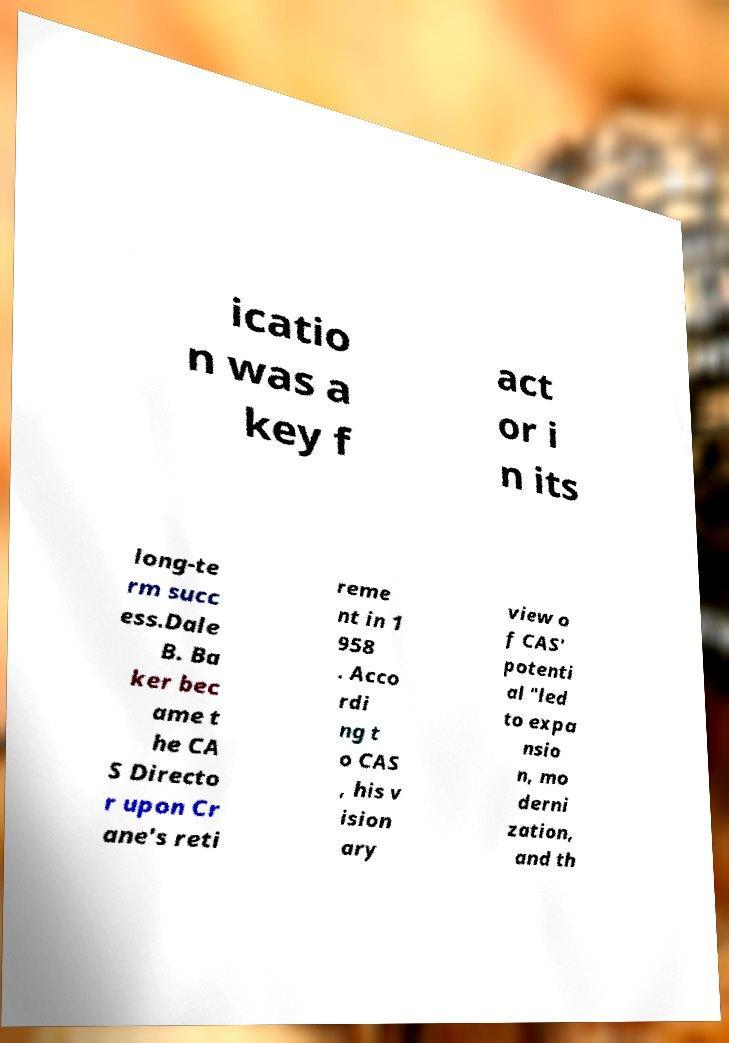Can you accurately transcribe the text from the provided image for me? icatio n was a key f act or i n its long-te rm succ ess.Dale B. Ba ker bec ame t he CA S Directo r upon Cr ane's reti reme nt in 1 958 . Acco rdi ng t o CAS , his v ision ary view o f CAS' potenti al "led to expa nsio n, mo derni zation, and th 